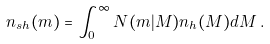<formula> <loc_0><loc_0><loc_500><loc_500>n _ { s h } ( m ) = \int _ { 0 } ^ { \infty } N ( m | M ) n _ { h } ( M ) d M \, .</formula> 